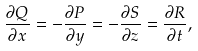<formula> <loc_0><loc_0><loc_500><loc_500>\frac { \partial Q } { \partial x } = - \frac { \partial P } { \partial y } = - \frac { \partial S } { \partial z } = \frac { \partial R } { \partial t } ,</formula> 